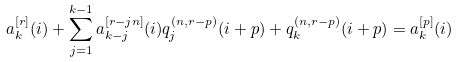<formula> <loc_0><loc_0><loc_500><loc_500>a _ { k } ^ { [ r ] } ( i ) + \sum _ { j = 1 } ^ { k - 1 } a _ { k - j } ^ { [ r - j n ] } ( i ) q _ { j } ^ { ( n , r - p ) } ( i + p ) + q _ { k } ^ { ( n , r - p ) } ( i + p ) = a _ { k } ^ { [ p ] } ( i )</formula> 